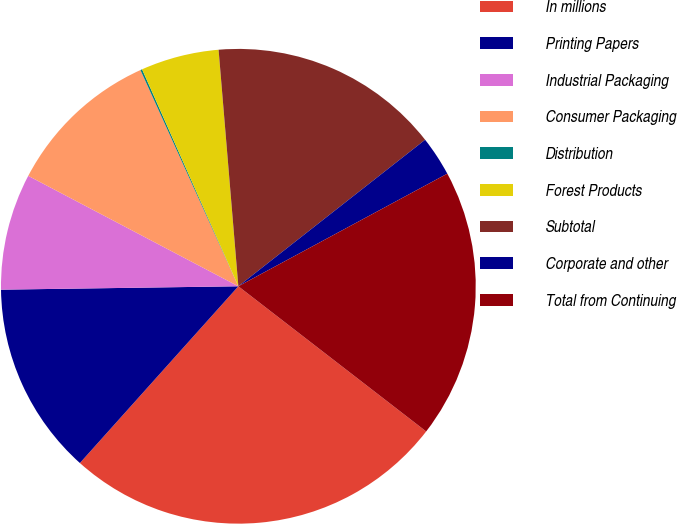Convert chart. <chart><loc_0><loc_0><loc_500><loc_500><pie_chart><fcel>In millions<fcel>Printing Papers<fcel>Industrial Packaging<fcel>Consumer Packaging<fcel>Distribution<fcel>Forest Products<fcel>Subtotal<fcel>Corporate and other<fcel>Total from Continuing<nl><fcel>26.16%<fcel>13.14%<fcel>7.93%<fcel>10.53%<fcel>0.12%<fcel>5.32%<fcel>15.74%<fcel>2.72%<fcel>18.34%<nl></chart> 